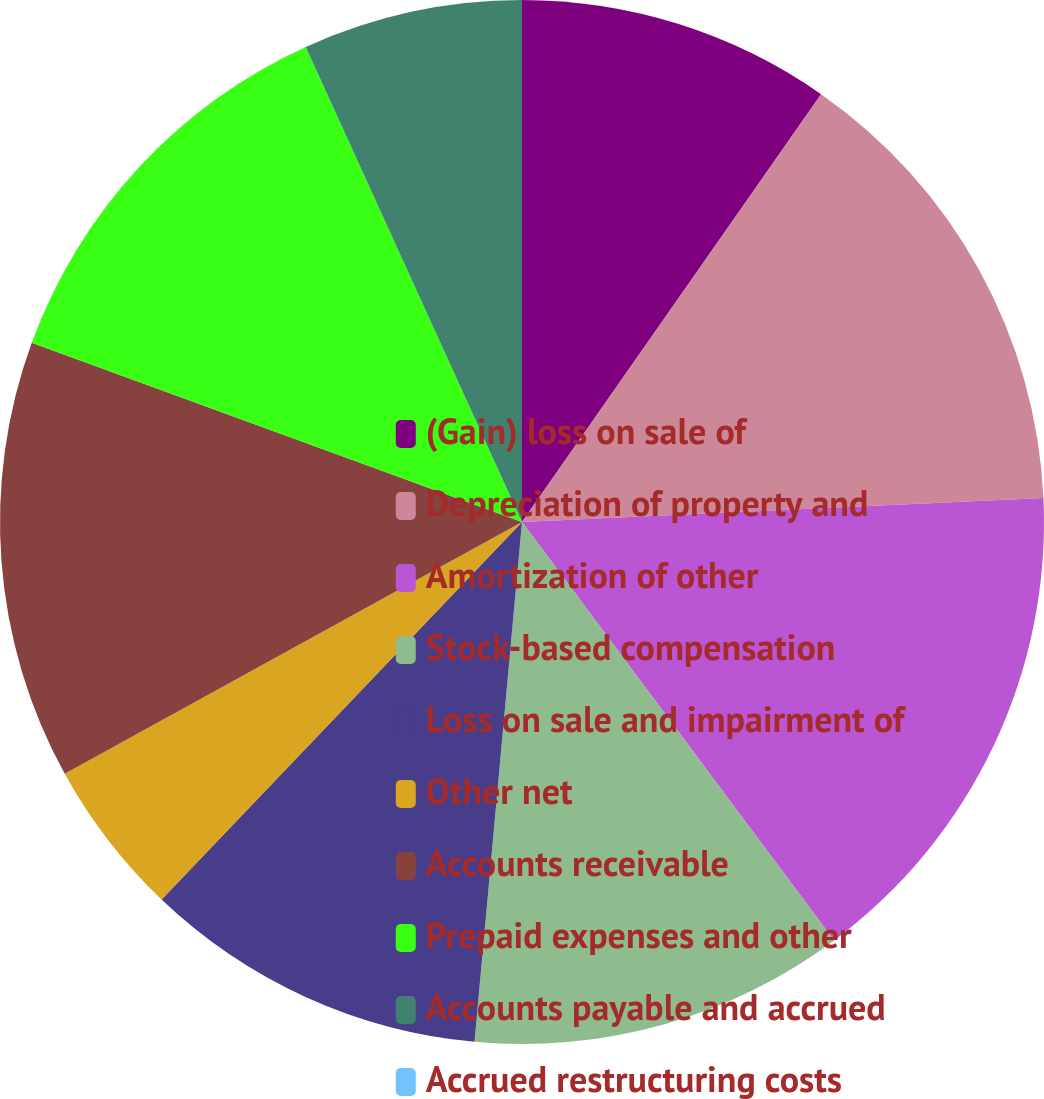<chart> <loc_0><loc_0><loc_500><loc_500><pie_chart><fcel>(Gain) loss on sale of<fcel>Depreciation of property and<fcel>Amortization of other<fcel>Stock-based compensation<fcel>Loss on sale and impairment of<fcel>Other net<fcel>Accounts receivable<fcel>Prepaid expenses and other<fcel>Accounts payable and accrued<fcel>Accrued restructuring costs<nl><fcel>9.71%<fcel>14.56%<fcel>15.53%<fcel>11.65%<fcel>10.68%<fcel>4.86%<fcel>13.59%<fcel>12.62%<fcel>6.8%<fcel>0.0%<nl></chart> 